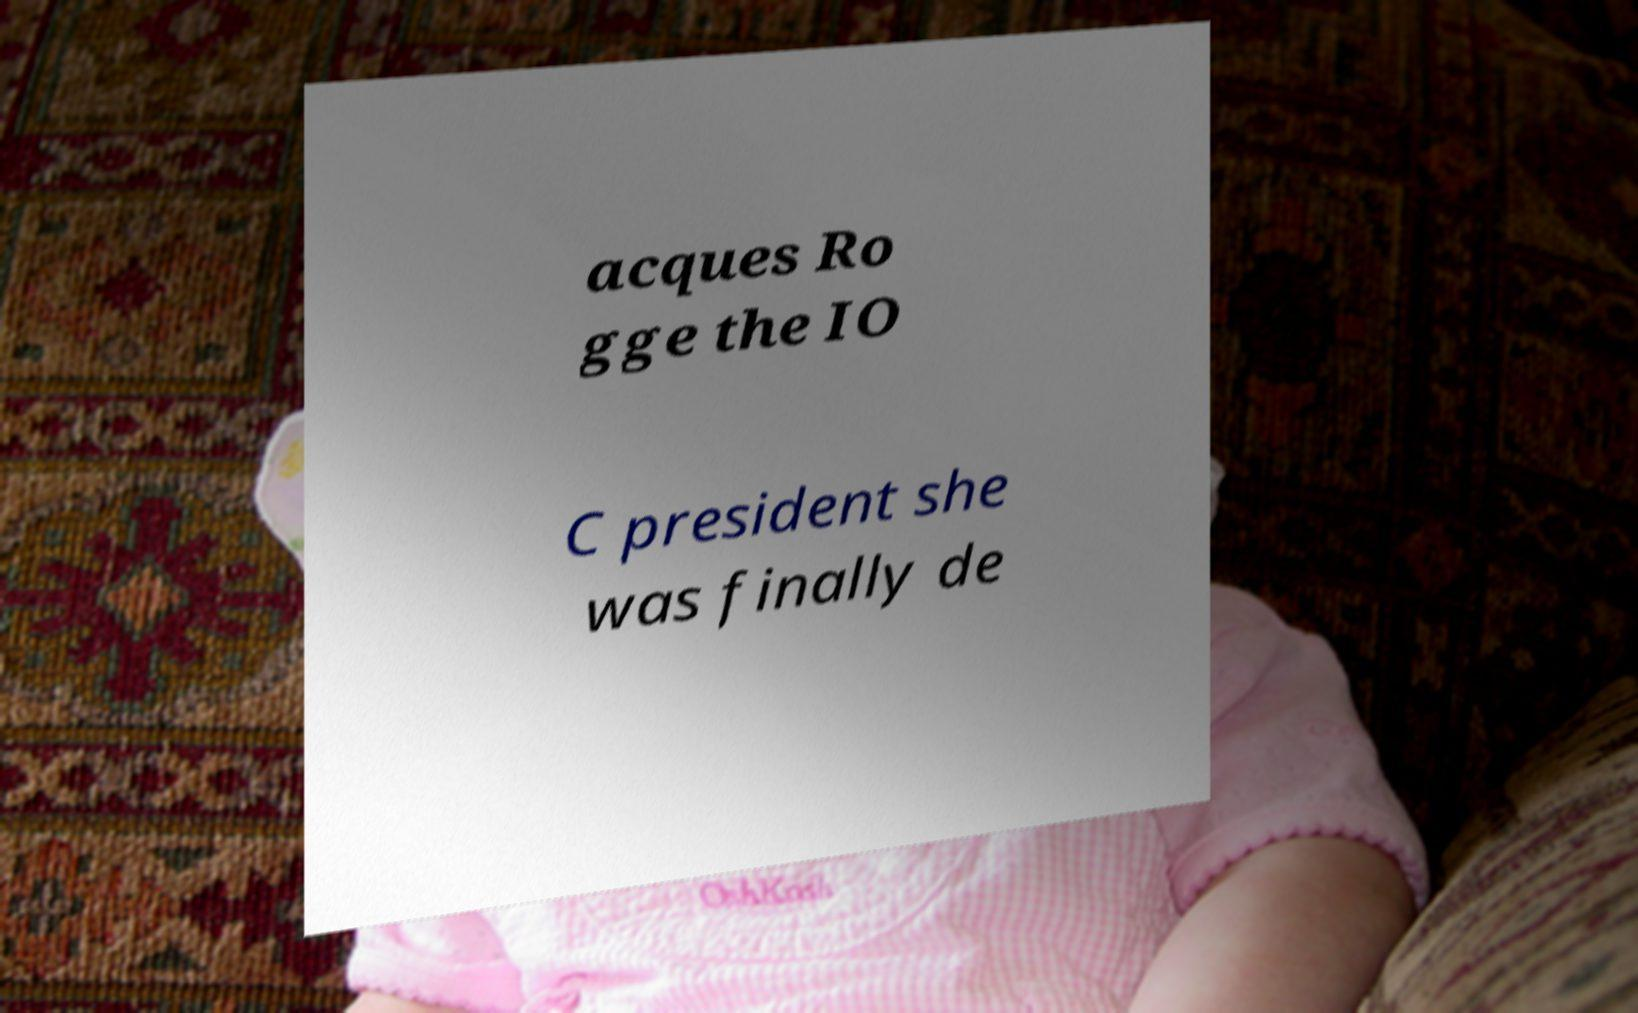Can you read and provide the text displayed in the image?This photo seems to have some interesting text. Can you extract and type it out for me? acques Ro gge the IO C president she was finally de 